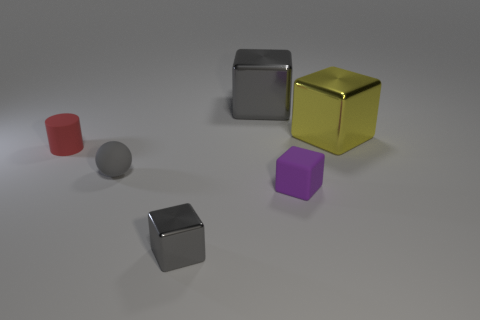Are the red cylinder and the small gray ball made of the same material?
Provide a succinct answer. Yes. What is the shape of the purple thing that is made of the same material as the tiny cylinder?
Provide a succinct answer. Cube. Are there fewer yellow rubber cylinders than tiny matte spheres?
Offer a terse response. Yes. There is a cube that is behind the small gray metal object and in front of the small rubber cylinder; what is it made of?
Ensure brevity in your answer.  Rubber. What size is the gray thing left of the gray block in front of the big gray block that is to the right of the gray rubber sphere?
Your answer should be very brief. Small. There is a large yellow metal object; does it have the same shape as the gray metallic object that is in front of the red object?
Offer a very short reply. Yes. What number of metallic cubes are both behind the red cylinder and in front of the red rubber cylinder?
Your answer should be very brief. 0. How many yellow things are either big metal cylinders or large cubes?
Provide a succinct answer. 1. There is a tiny rubber object on the right side of the small shiny thing; is its color the same as the rubber object that is to the left of the small gray matte thing?
Provide a succinct answer. No. There is a big object left of the big thing that is to the right of the tiny purple matte thing in front of the cylinder; what is its color?
Provide a short and direct response. Gray. 